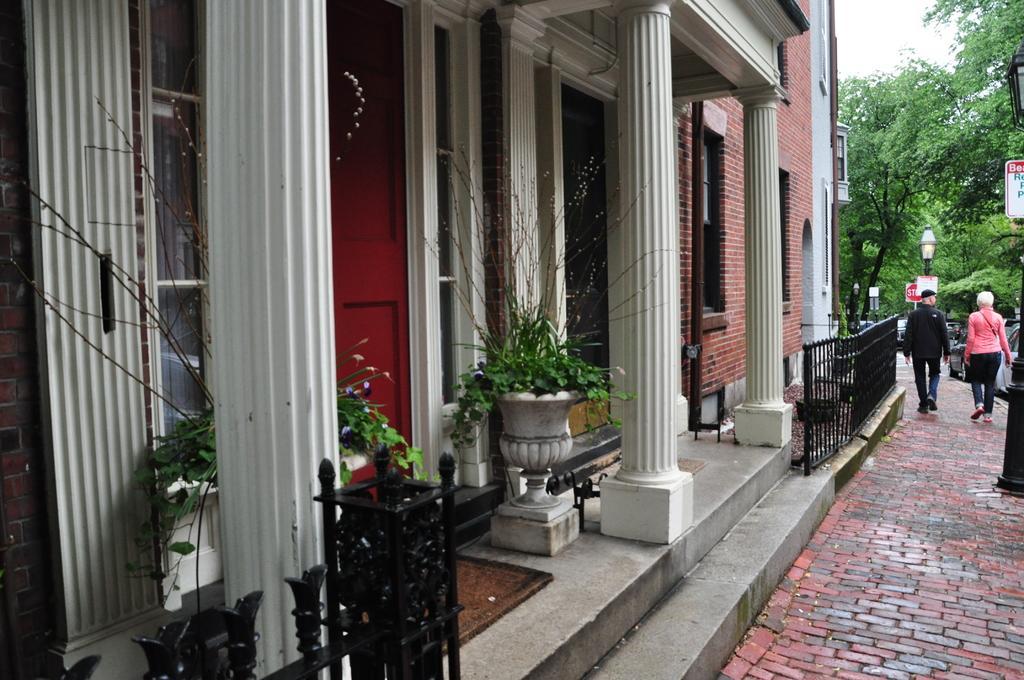Describe this image in one or two sentences. In this image at front there is a building and at the center there is a door. In front of the door there are two flower pots. We can see metal fence. In front of the building there are street lights. Two People are walking on the road. At the back side there are trees and sky. 